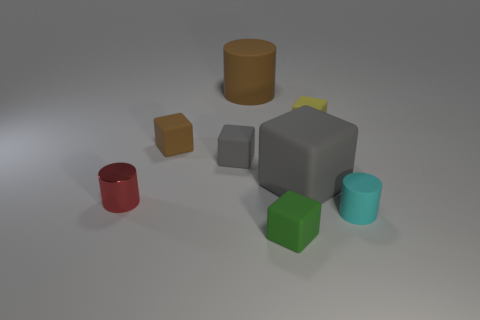Subtract all big gray cubes. How many cubes are left? 4 Subtract all green cubes. How many cubes are left? 4 Subtract all red cubes. Subtract all green cylinders. How many cubes are left? 5 Add 2 gray rubber cylinders. How many objects exist? 10 Subtract all cylinders. How many objects are left? 5 Subtract 0 red balls. How many objects are left? 8 Subtract all tiny rubber cylinders. Subtract all gray matte things. How many objects are left? 5 Add 5 large rubber blocks. How many large rubber blocks are left? 6 Add 3 big brown metal things. How many big brown metal things exist? 3 